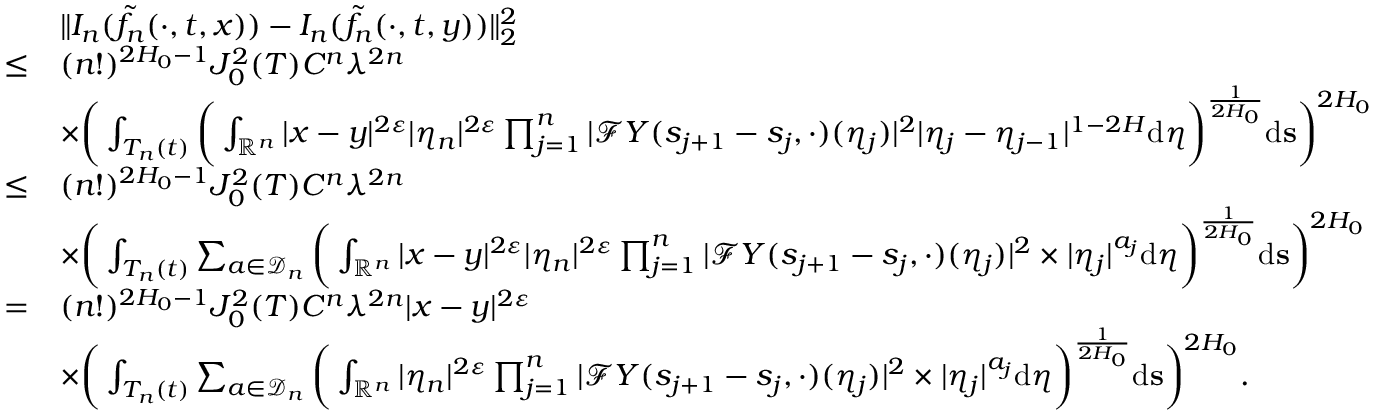Convert formula to latex. <formula><loc_0><loc_0><loc_500><loc_500>\begin{array} { r l } & { \| I _ { n } ( \tilde { f _ { n } } ( \cdot , t , x ) ) - I _ { n } ( \tilde { f _ { n } } ( \cdot , t , y ) ) \| _ { 2 } ^ { 2 } } \\ { \leq } & { ( n ! ) ^ { 2 H _ { 0 } - 1 } J _ { 0 } ^ { 2 } ( T ) C ^ { n } \lambda ^ { 2 n } } \\ & { \times \left ( \int _ { T _ { n } ( t ) } \left ( \int _ { \mathbb { R } ^ { n } } | x - y | ^ { 2 \varepsilon } | \eta _ { n } | ^ { 2 \varepsilon } \prod _ { j = 1 } ^ { n } | \mathcal { F } Y ( s _ { j + 1 } - s _ { j } , \cdot ) ( \eta _ { j } ) | ^ { 2 } | \eta _ { j } - \eta _ { j - 1 } | ^ { 1 - 2 H } { d } \boldsymbol \eta \right ) ^ { \frac { 1 } { 2 H _ { 0 } } } { d } s \right ) ^ { 2 H _ { 0 } } } \\ { \leq } & { ( n ! ) ^ { 2 H _ { 0 } - 1 } J _ { 0 } ^ { 2 } ( T ) C ^ { n } \lambda ^ { 2 n } } \\ & { \times \left ( \int _ { T _ { n } ( t ) } \sum _ { a \in \mathcal { D } _ { n } } \left ( \int _ { \mathbb { R } ^ { n } } | x - y | ^ { 2 \varepsilon } | \eta _ { n } | ^ { 2 \varepsilon } \prod _ { j = 1 } ^ { n } | \mathcal { F } Y ( s _ { j + 1 } - s _ { j } , \cdot ) ( \eta _ { j } ) | ^ { 2 } \times | \eta _ { j } | ^ { a _ { j } } { d } \boldsymbol \eta \right ) ^ { \frac { 1 } { 2 H _ { 0 } } } { d } \mathbf s \right ) ^ { 2 H _ { 0 } } } \\ { = } & { ( n ! ) ^ { 2 H _ { 0 } - 1 } J _ { 0 } ^ { 2 } ( T ) C ^ { n } \lambda ^ { 2 n } | x - y | ^ { 2 \varepsilon } } \\ & { \times \left ( \int _ { T _ { n } ( t ) } \sum _ { a \in \mathcal { D } _ { n } } \left ( \int _ { \mathbb { R } ^ { n } } | \eta _ { n } | ^ { 2 \varepsilon } \prod _ { j = 1 } ^ { n } | \mathcal { F } Y ( s _ { j + 1 } - s _ { j } , \cdot ) ( \eta _ { j } ) | ^ { 2 } \times | \eta _ { j } | ^ { a _ { j } } { d } \boldsymbol \eta \right ) ^ { \frac { 1 } { 2 H _ { 0 } } } { d } \mathbf s \right ) ^ { 2 H _ { 0 } } . } \end{array}</formula> 